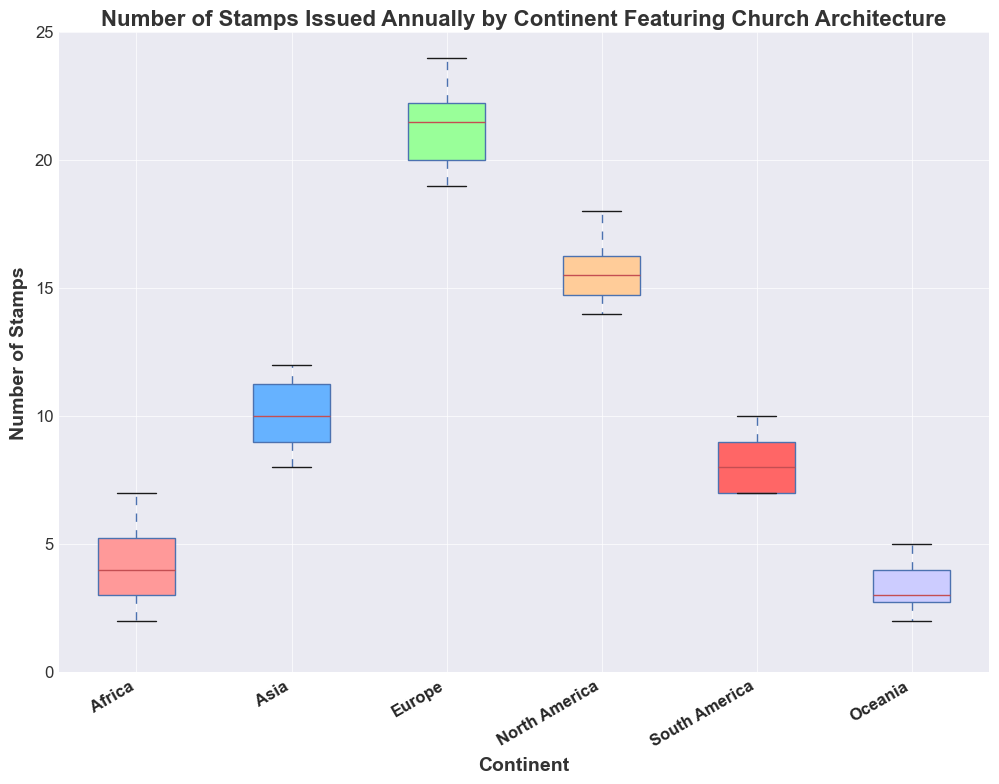Which continent has the highest median number of stamps issued annually featuring church architecture? By analyzing the box plot, identify the continent with the highest middle value for the number of stamps. The median is represented by the line inside the box.
Answer: Europe What is the interquartile range (IQR) for Asia? The IQR is the difference between the third quartile (Q3, top of the box) and the first quartile (Q1, bottom of the box). Look at the edges of the box for Asia and calculate the difference.
Answer: 2 (12 - 10) Which continent shows the least variation in the number of stamps issued annually? The variation is represented by the length of the box and whiskers. Find the continent with the smallest box and whiskers combined.
Answer: Africa How does the number of stamps issued annually in North America compare to South America in terms of range? The range is the difference between the maximum and minimum values. Assess the lengths of the whiskers for North America and South America to compare their ranges.
Answer: North America has a larger range Which continent's box in the box plot has the largest spread? Look at the length of the boxes to determine which continent's box is the longest, indicating the largest spread in the data.
Answer: Europe How does the median number of stamps issued in Oceania compare to that in Africa? Analyze the median lines (inside the boxes) for both Oceania and Africa. The continent with the higher median will have a higher line.
Answer: Oceania's median is slightly lower than Africa's Which continent's box plot indicates potential outliers? Look for data points that fall outside the whiskers. The continent with dots or stars outside the whiskers indicates potential outliers.
Answer: No obvious outliers in the given data Is the average number of stamps issued annually in Europe higher than that of Asia? The average can be inferred from the position and spread of the box plots. Europe has a higher median and larger interquartile range compared to Asia, suggesting a higher average.
Answer: Yes How does the median number of stamps in South America compare to the first quartile of North America? Identify the median line inside the South America box and the bottom of the box (Q1) for North America, then compare their positions.
Answer: South America's median is lower than North America's Q1 What is the most common number of stamps issued annually in Africa? The most common value (mode) might coincide with the median or box plot's data concentration. The median for Africa is the most typical value.
Answer: 4 